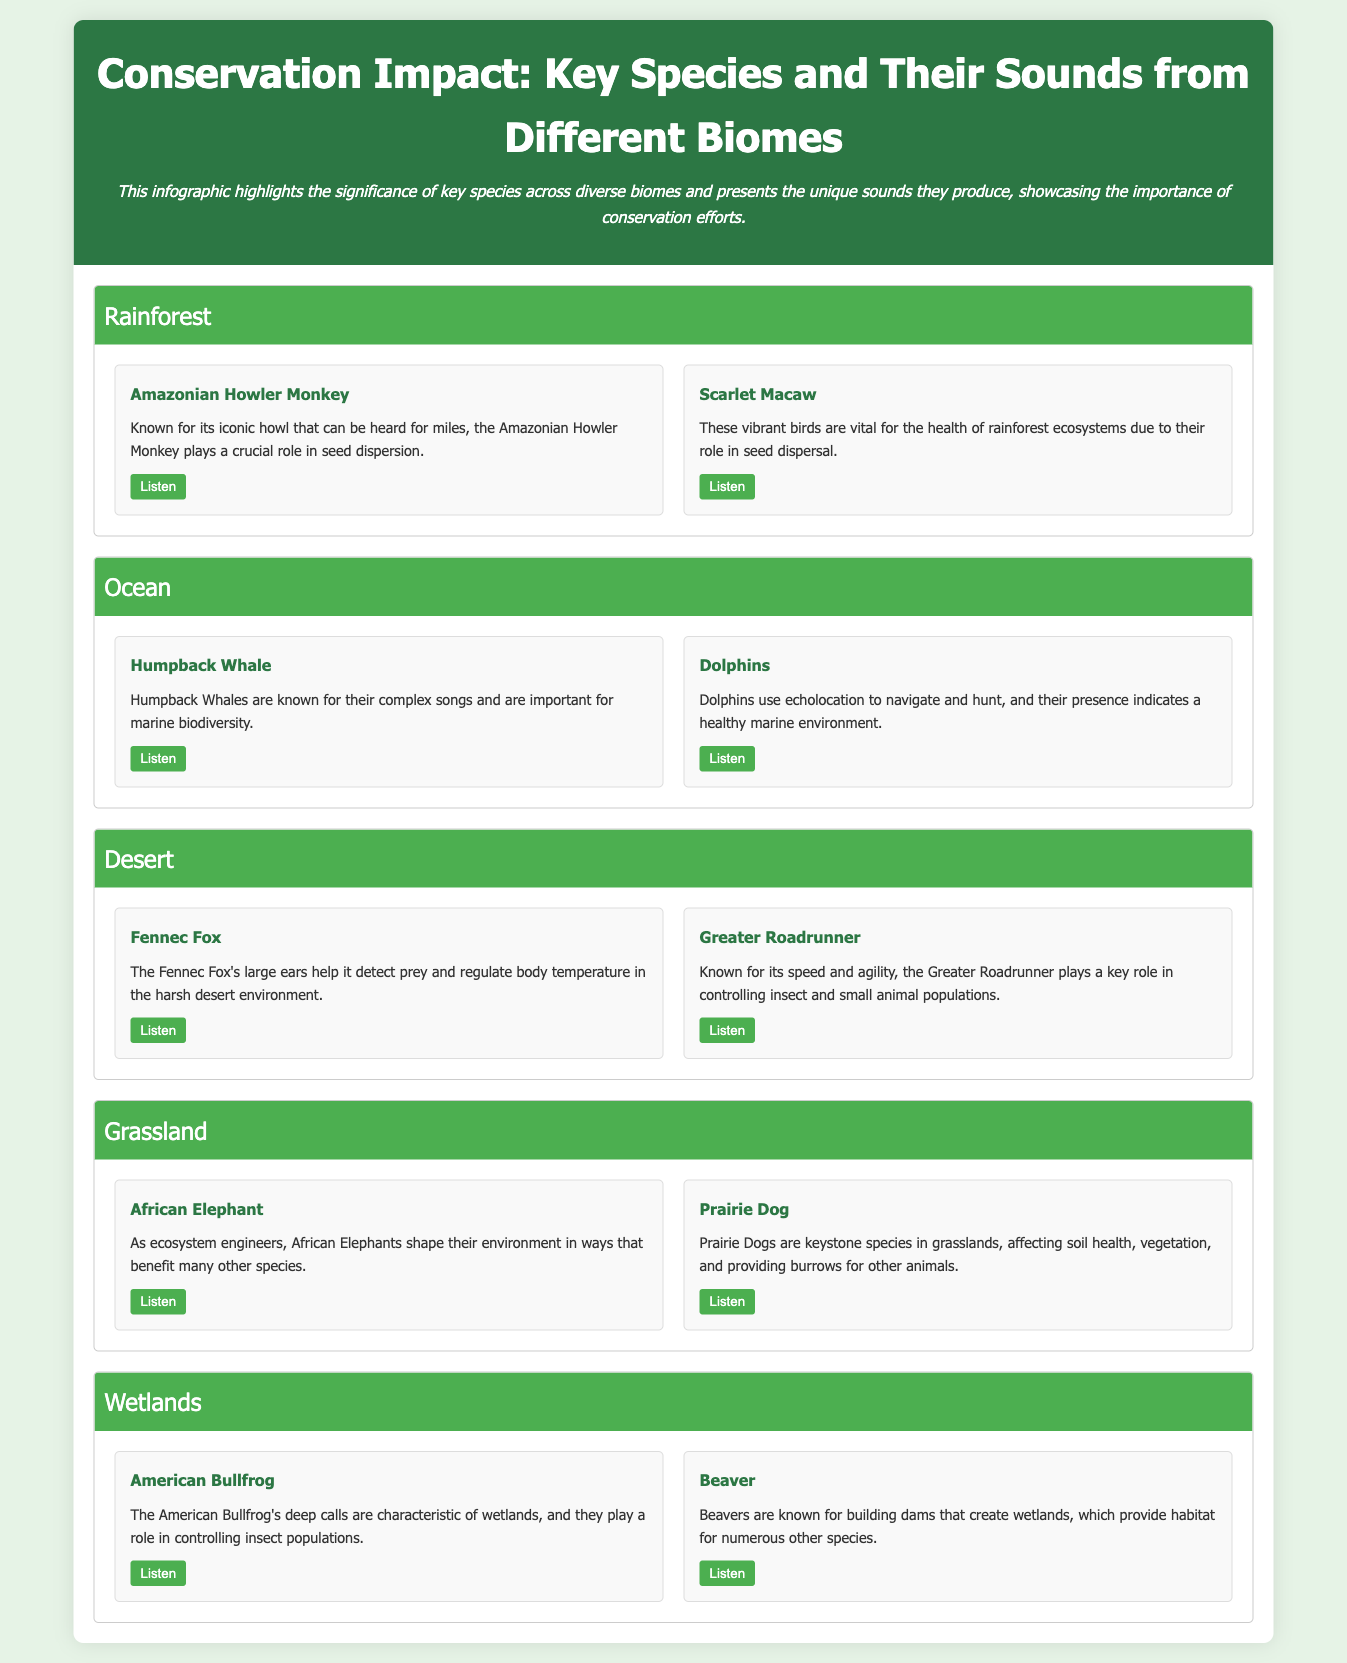What is the title of the infographic? The title is presented at the top of the document to summarize its content.
Answer: Conservation Impact: Key Species and Their Sounds from Different Biomes How many species are listed for the Rainforest biome? The document presents two species cards in the Rainforest section, each representing a species.
Answer: 2 Which animal is known for its iconic howl in the Rainforest? The species card specifically highlights the Amazonian Howler Monkey for its recognizable sound.
Answer: Amazonian Howler Monkey What role do African Elephants play in the Grassland biome? The description in the Grassland section details their function in shaping the environment, benefiting other species.
Answer: Ecosystem engineers What is the sound associated with the Humpback Whale? The document describes the sound as complex songs which the Humpback Whale is known for.
Answer: Complex songs 